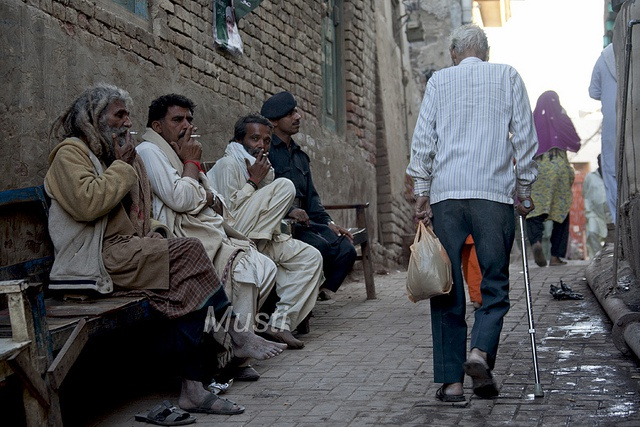Describe the objects in this image and their specific colors. I can see people in gray and black tones, people in gray, black, and darkgray tones, bench in gray and black tones, people in gray, darkgray, and black tones, and people in gray, darkgray, and black tones in this image. 